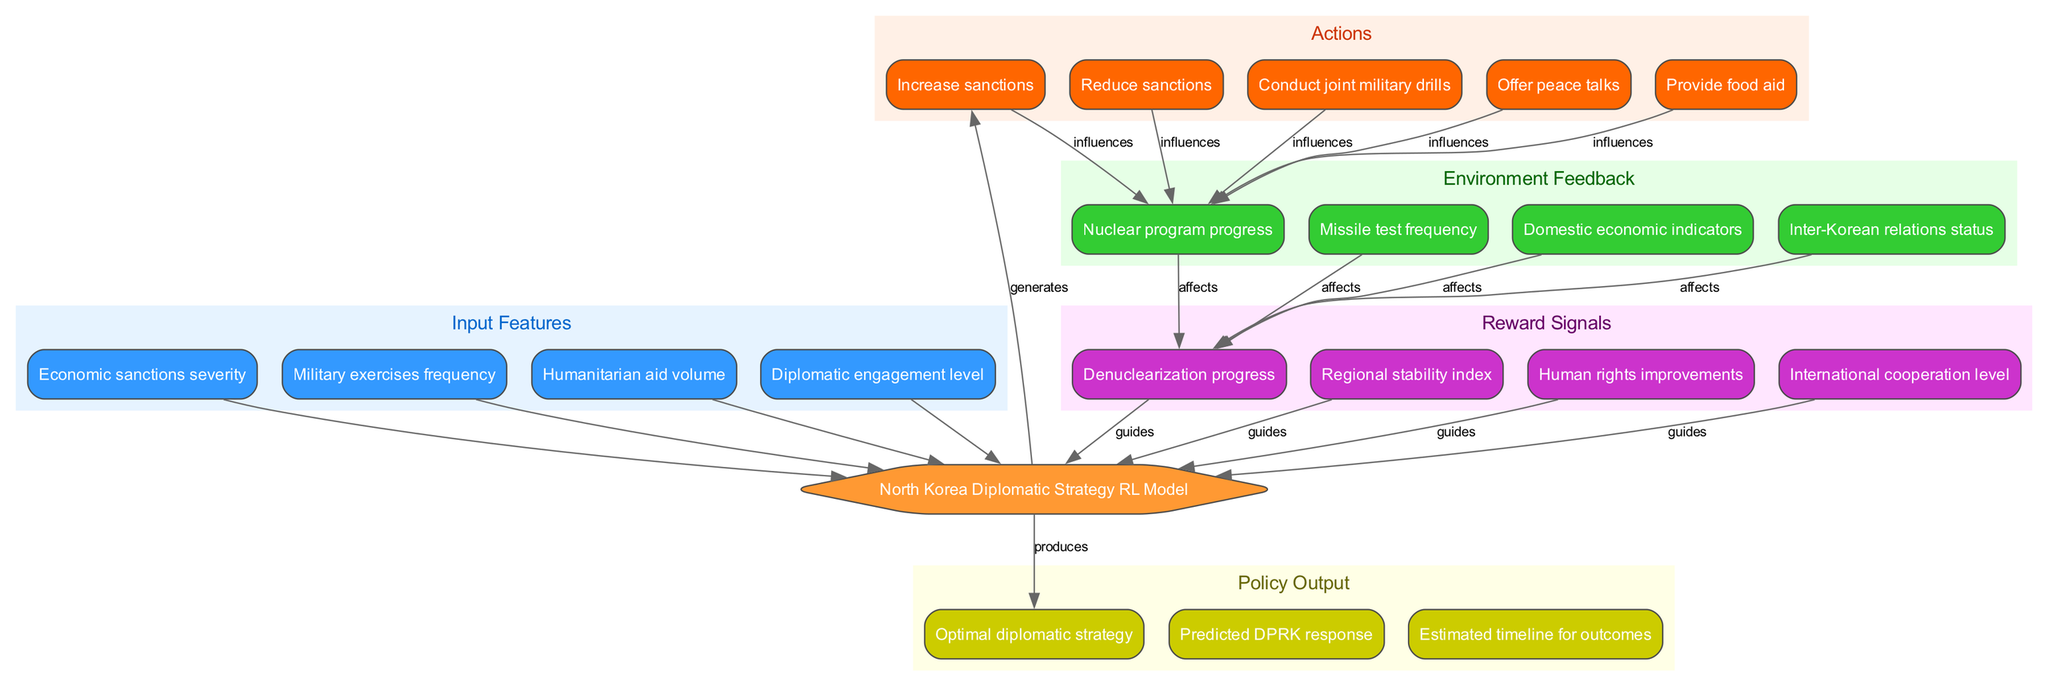What are the input features of the model? The model incorporates four specific input features which are grouped under the "Input Features" cluster. These features can be directly read from the diagram.
Answer: Economic sanctions severity, Military exercises frequency, Humanitarian aid volume, Diplomatic engagement level How many actions are represented in the diagram? The "Actions" cluster in the diagram contains five individual actions that can be undertaken. This count can be ascertained by counting the nodes in that section.
Answer: 5 Which action influences nuclear program progress? In the diagram, all actions connect to the environment feedback, which includes nuclear program progress. Specifically, it can be deduced that actions like increasing or reducing sanctions and conducting military drills could impact this outcome.
Answer: All actions What is produced as a result of the model? The output of the model is described under the "Policy Output" section of the diagram. The model directly leads to the generation of optimal strategy decisions.
Answer: Optimal diplomatic strategy Which feedback signal guides the model? The feedback signals influence the model's decisions regarding actions. In the diagram, one can observe that each signal counts towards guiding the decision-making process.
Answer: Denuclearization progress How does humanitarian aid volume relate to the model? Humanitarian aid volume is one of the core input features that feed into the model. It indicates that adjustments in this area can influence model outputs and actions.
Answer: Influences model What is the relationship between environment feedback and reward signals? The environment feedback nodes, which include indicators like missile test frequency and inter-Korean relations status, are linked to reward signals. This connection signifies that feedback directly affects the reward signals provided to the model.
Answer: Affects What happens if sanctions are increased? The diagram specifies that increasing sanctions is one of the actions that influences multiple aspects of environment feedback, including nuclear program progress and missile test frequency.
Answer: Influences feedback What does the model output regarding DPRK response? The model produces a specific output related to the predicted DPRK response, which is part of the "Policy Output" cluster. This output is intended to guide decision-making in diplomatic strategies.
Answer: Predicted DPRK response 